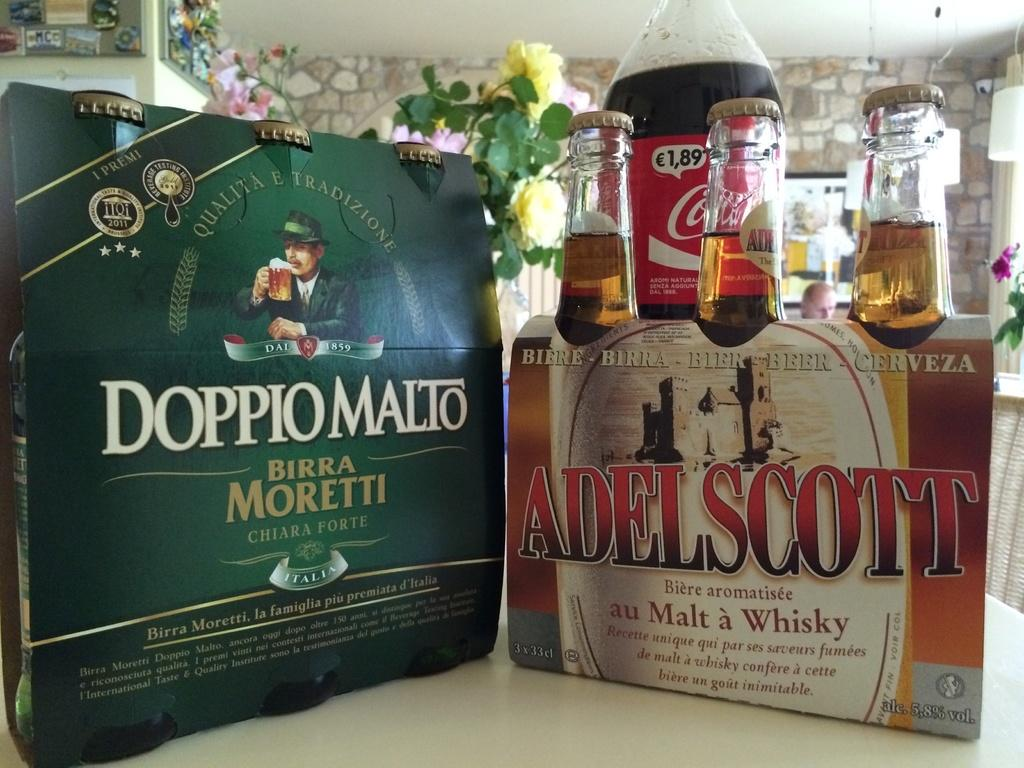What objects can be seen in the image? There are bottles, a plant with a yellow flower, and a poster in the image. Can you describe the plant in the image? The plant has a yellow flower. What is visible in the background of the image? There is a wall and pink flowers in the background of the image. What type of decoration is present in the image? The poster is a type of decoration in the image. How many mice are hiding behind the bottles in the image? There are no mice present in the image. What type of sign is hanging on the wall in the image? There is no sign hanging on the wall in the image. 